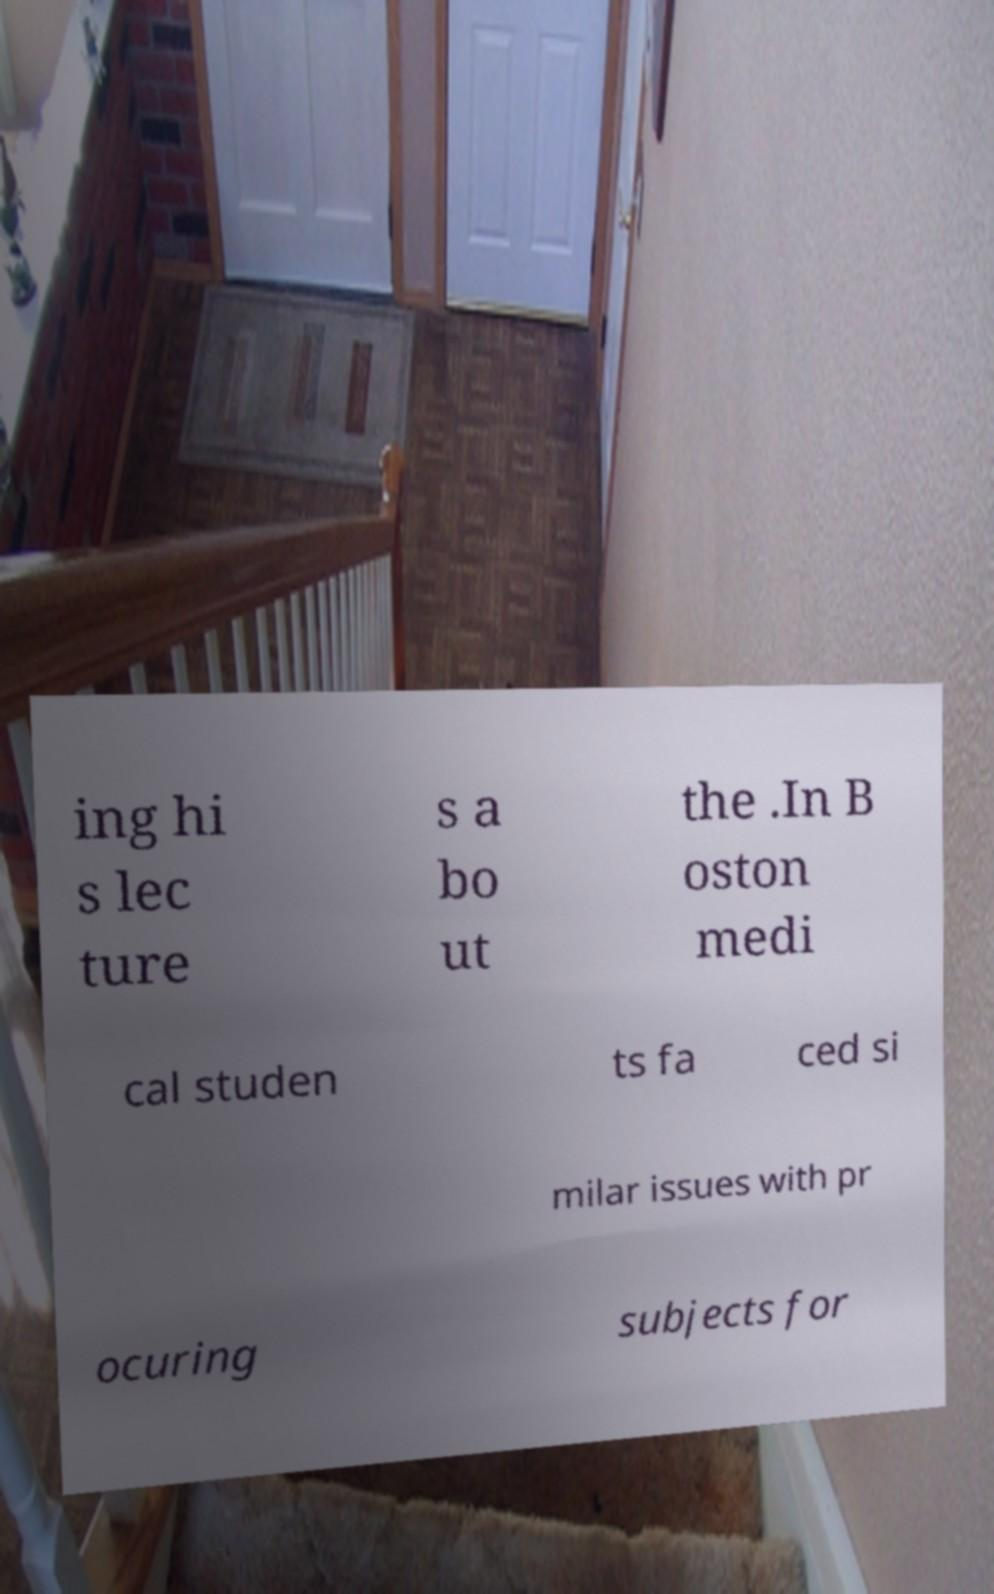For documentation purposes, I need the text within this image transcribed. Could you provide that? ing hi s lec ture s a bo ut the .In B oston medi cal studen ts fa ced si milar issues with pr ocuring subjects for 